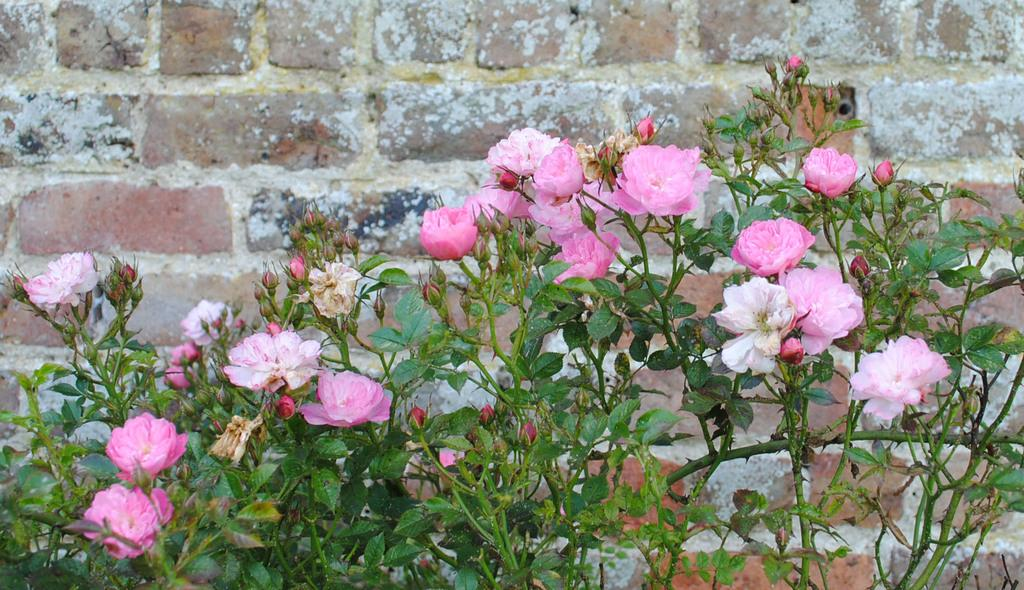What type of plant is in the image? There is a pink flower plant in the image. Where is the pink flower plant located in the image? The pink flower plant is in the front of the image. What is behind the pink flower plant in the image? There is a brick wall behind the pink flower plant. Can you see the partner of the pink flower plant in the image? There is no partner of the pink flower plant present in the image. What type of pin is holding the pink flower plant to the brick wall? There is no pin visible in the image, and the pink flower plant is not attached to the brick wall. 